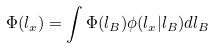Convert formula to latex. <formula><loc_0><loc_0><loc_500><loc_500>\Phi ( l _ { x } ) = \int \Phi ( l _ { B } ) \phi ( l _ { x } | l _ { B } ) d l _ { B }</formula> 